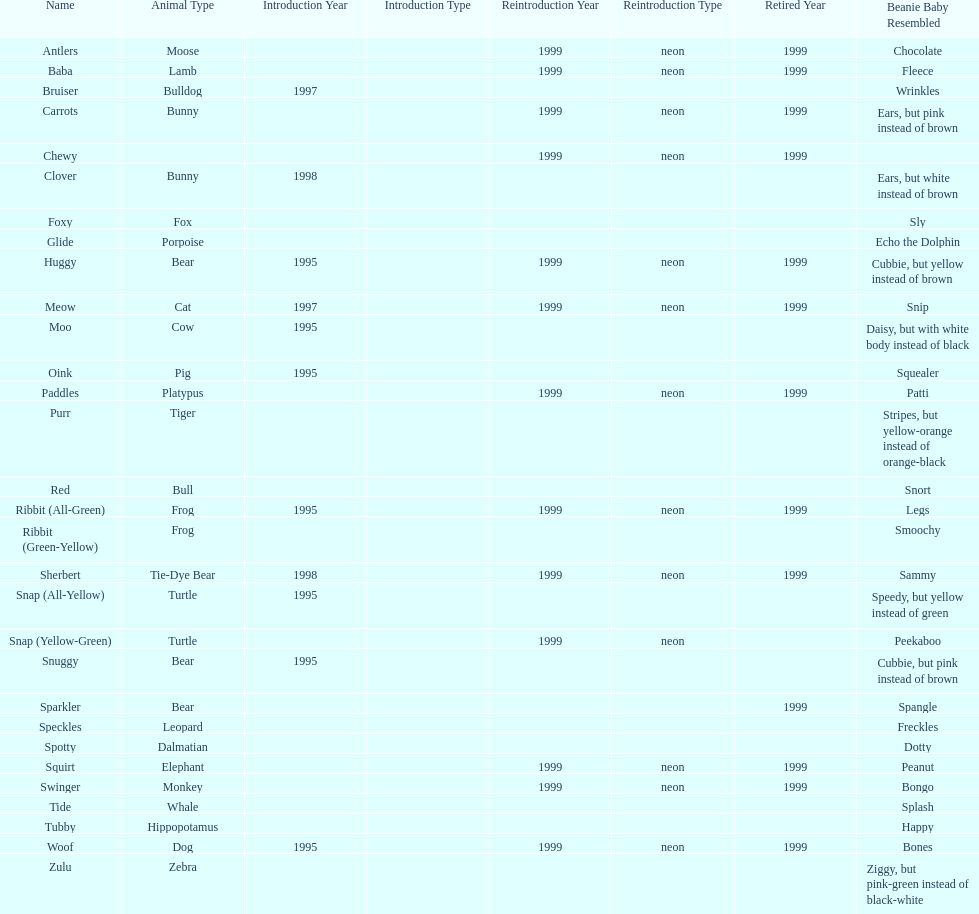How many monkey pillow pals were there? 1. Help me parse the entirety of this table. {'header': ['Name', 'Animal Type', 'Introduction Year', 'Introduction Type', 'Reintroduction Year', 'Reintroduction Type', 'Retired Year', 'Beanie Baby Resembled'], 'rows': [['Antlers', 'Moose', '', '', '1999', 'neon', '1999', 'Chocolate'], ['Baba', 'Lamb', '', '', '1999', 'neon', '1999', 'Fleece'], ['Bruiser', 'Bulldog', '1997', '', '', '', '', 'Wrinkles'], ['Carrots', 'Bunny', '', '', '1999', 'neon', '1999', 'Ears, but pink instead of brown'], ['Chewy', '', '', '', '1999', 'neon', '1999', ''], ['Clover', 'Bunny', '1998', '', '', '', '', 'Ears, but white instead of brown'], ['Foxy', 'Fox', '', '', '', '', '', 'Sly'], ['Glide', 'Porpoise', '', '', '', '', '', 'Echo the Dolphin'], ['Huggy', 'Bear', '1995', '', '1999', 'neon', '1999', 'Cubbie, but yellow instead of brown'], ['Meow', 'Cat', '1997', '', '1999', 'neon', '1999', 'Snip'], ['Moo', 'Cow', '1995', '', '', '', '', 'Daisy, but with white body instead of black'], ['Oink', 'Pig', '1995', '', '', '', '', 'Squealer'], ['Paddles', 'Platypus', '', '', '1999', 'neon', '1999', 'Patti'], ['Purr', 'Tiger', '', '', '', '', '', 'Stripes, but yellow-orange instead of orange-black'], ['Red', 'Bull', '', '', '', '', '', 'Snort'], ['Ribbit (All-Green)', 'Frog', '1995', '', '1999', 'neon', '1999', 'Legs'], ['Ribbit (Green-Yellow)', 'Frog', '', '', '', '', '', 'Smoochy'], ['Sherbert', 'Tie-Dye Bear', '1998', '', '1999', 'neon', '1999', 'Sammy'], ['Snap (All-Yellow)', 'Turtle', '1995', '', '', '', '', 'Speedy, but yellow instead of green'], ['Snap (Yellow-Green)', 'Turtle', '', '', '1999', 'neon', '', 'Peekaboo'], ['Snuggy', 'Bear', '1995', '', '', '', '', 'Cubbie, but pink instead of brown'], ['Sparkler', 'Bear', '', '', '', '', '1999', 'Spangle'], ['Speckles', 'Leopard', '', '', '', '', '', 'Freckles'], ['Spotty', 'Dalmatian', '', '', '', '', '', 'Dotty'], ['Squirt', 'Elephant', '', '', '1999', 'neon', '1999', 'Peanut'], ['Swinger', 'Monkey', '', '', '1999', 'neon', '1999', 'Bongo'], ['Tide', 'Whale', '', '', '', '', '', 'Splash'], ['Tubby', 'Hippopotamus', '', '', '', '', '', 'Happy'], ['Woof', 'Dog', '1995', '', '1999', 'neon', '1999', 'Bones'], ['Zulu', 'Zebra', '', '', '', '', '', 'Ziggy, but pink-green instead of black-white']]} 